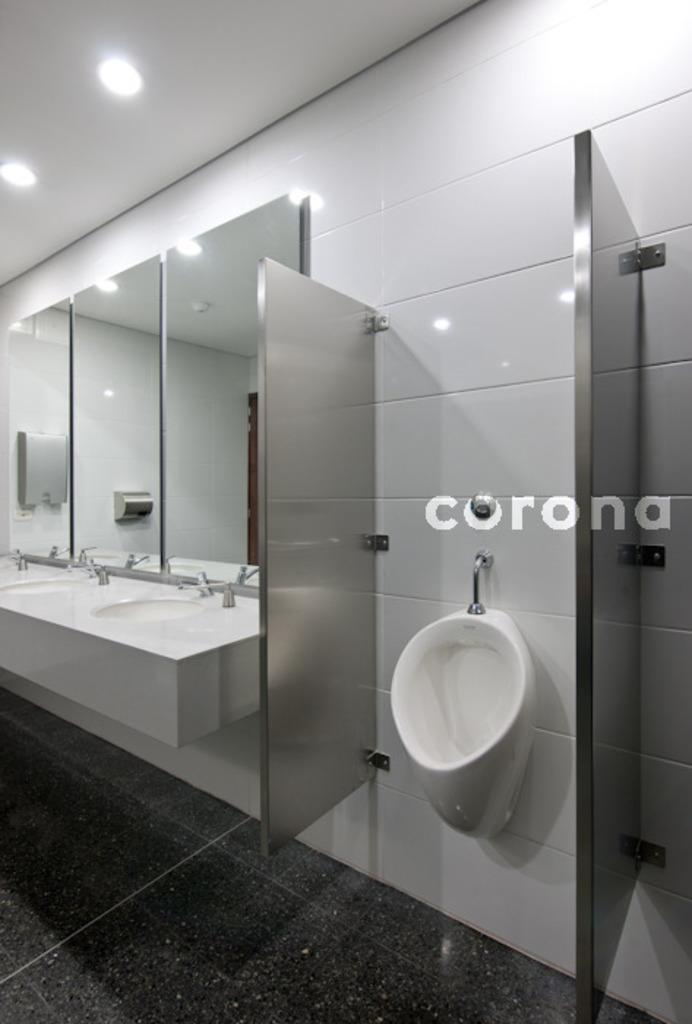What type of fixture is located in the center of the image? There is a white color toilet in the image. What can be found on the left side of the image? There are washbasins on the left side of the image. What is used for reflecting images in the image? There are mirrors in the image. What color is the wall in the background of the image? There is a white color wall in the background of the image. What type of volleyball is being used as a decoration in the image? There is no volleyball present in the image; it is a bathroom setting with a toilet, washbasins, mirrors, and a white wall. 